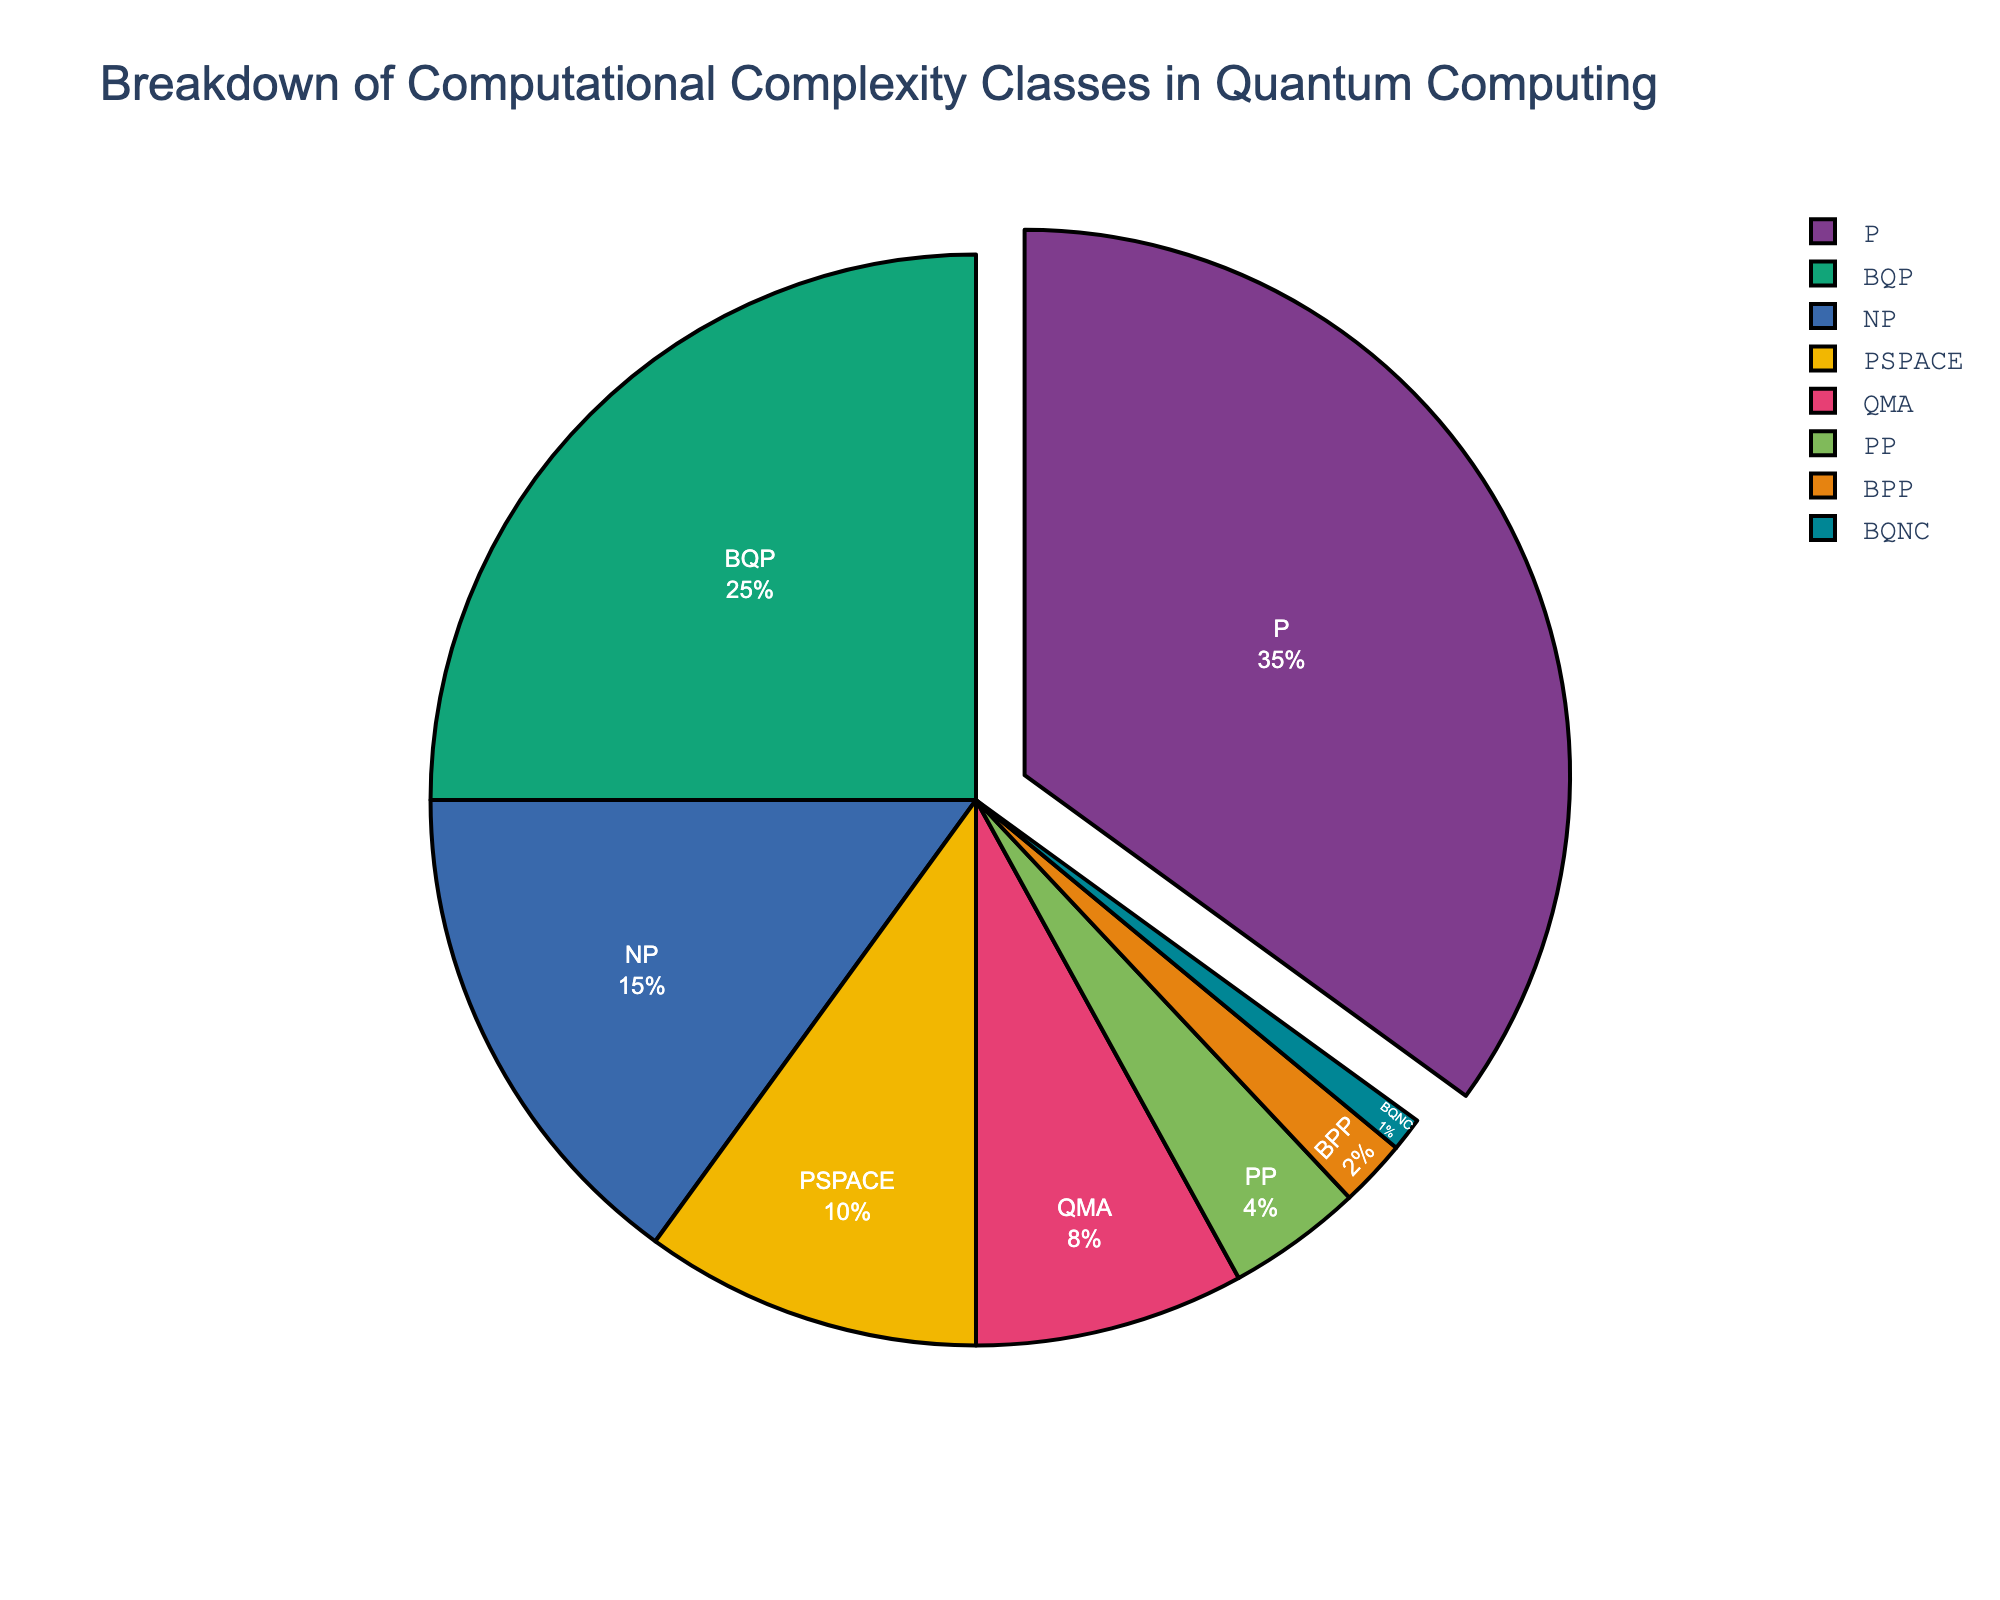What's the largest category in the pie chart? The largest category corresponds to the slice with the highest percentage. In this case, it is P, which occupies 35% of the chart.
Answer: P Which category has a higher percentage: BQP or NP? To determine which has a higher percentage, compare their given percentages. BQP is 25% while NP is 15%.
Answer: BQP What is the combined percentage of PSPACE and QMA? Add the percentages of PSPACE (10%) and QMA (8%). 10% + 8% = 18%.
Answer: 18% Which category is represented by the smallest slice, and what is its value? The smallest slice represents the category with the smallest percentage, which is BQNC with 1%.
Answer: BQNC, 1% What is the difference in percentage between P and the second largest category? Subtract the percentage of the second largest category BQP (25%) from P (35%). 35% - 25% = 10%.
Answer: 10% How many categories make up more than 15% of the chart? Identify categories with percentages greater than 15%. P (35%) and BQP (25%) qualify. Two categories.
Answer: 2 What is the total percentage of categories with less than 10% each? Add the percentages of NP, PSPACE, QMA, PP, BPP, and BQNC. 15% + 10% + 8% + 4% + 2% + 1% = 40%.
Answer: 40% Which category is associated with a green slice in the chart? The slice colors follow a specific order, and identifying the colors requires visual inspection. However, without the actual image, we assume the predefined palette assigns green to the slice representing NP, as it is third in the ordering.
Answer: NP What is the difference in percentage between PP and BPP? Subtract the percentage of BPP (2%) from PP (4%). 4% - 2% = 2%.
Answer: 2% Which category represents a percentage that is one-fourth of P? Calculate one-fourth of P's percentage: 35% / 4 = 8.75%. The closest percentage to this value is QMA with 8%.
Answer: QMA 